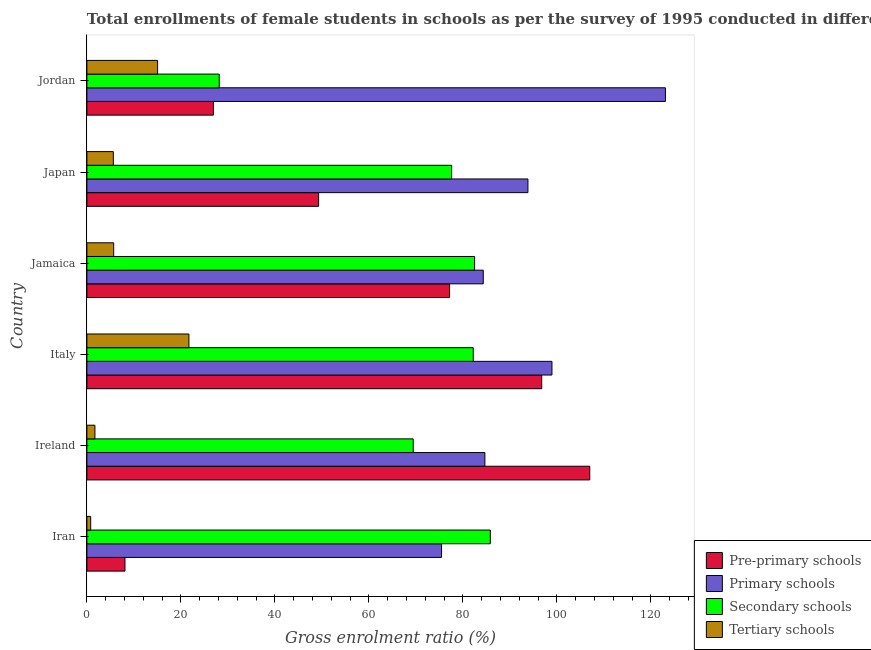Are the number of bars per tick equal to the number of legend labels?
Your response must be concise. Yes. How many bars are there on the 5th tick from the bottom?
Provide a short and direct response. 4. What is the label of the 4th group of bars from the top?
Make the answer very short. Italy. In how many cases, is the number of bars for a given country not equal to the number of legend labels?
Your response must be concise. 0. What is the gross enrolment ratio(female) in primary schools in Italy?
Offer a very short reply. 98.95. Across all countries, what is the maximum gross enrolment ratio(female) in pre-primary schools?
Make the answer very short. 106.99. Across all countries, what is the minimum gross enrolment ratio(female) in pre-primary schools?
Your answer should be very brief. 8.1. In which country was the gross enrolment ratio(female) in pre-primary schools maximum?
Offer a terse response. Ireland. In which country was the gross enrolment ratio(female) in tertiary schools minimum?
Your answer should be very brief. Iran. What is the total gross enrolment ratio(female) in pre-primary schools in the graph?
Your answer should be compact. 365.24. What is the difference between the gross enrolment ratio(female) in primary schools in Japan and that in Jordan?
Your answer should be very brief. -29.25. What is the difference between the gross enrolment ratio(female) in primary schools in Ireland and the gross enrolment ratio(female) in tertiary schools in Jordan?
Your response must be concise. 69.64. What is the average gross enrolment ratio(female) in primary schools per country?
Ensure brevity in your answer.  93.39. What is the difference between the gross enrolment ratio(female) in primary schools and gross enrolment ratio(female) in pre-primary schools in Jordan?
Keep it short and to the point. 96.18. What is the ratio of the gross enrolment ratio(female) in primary schools in Iran to that in Ireland?
Your answer should be very brief. 0.89. Is the difference between the gross enrolment ratio(female) in secondary schools in Iran and Japan greater than the difference between the gross enrolment ratio(female) in pre-primary schools in Iran and Japan?
Your response must be concise. Yes. What is the difference between the highest and the second highest gross enrolment ratio(female) in primary schools?
Ensure brevity in your answer.  24.14. What is the difference between the highest and the lowest gross enrolment ratio(female) in tertiary schools?
Give a very brief answer. 20.9. What does the 2nd bar from the top in Japan represents?
Offer a terse response. Secondary schools. What does the 2nd bar from the bottom in Jamaica represents?
Provide a succinct answer. Primary schools. Is it the case that in every country, the sum of the gross enrolment ratio(female) in pre-primary schools and gross enrolment ratio(female) in primary schools is greater than the gross enrolment ratio(female) in secondary schools?
Ensure brevity in your answer.  No. Does the graph contain grids?
Your answer should be very brief. No. How many legend labels are there?
Keep it short and to the point. 4. What is the title of the graph?
Provide a short and direct response. Total enrollments of female students in schools as per the survey of 1995 conducted in different countries. What is the label or title of the Y-axis?
Ensure brevity in your answer.  Country. What is the Gross enrolment ratio (%) of Pre-primary schools in Iran?
Give a very brief answer. 8.1. What is the Gross enrolment ratio (%) of Primary schools in Iran?
Ensure brevity in your answer.  75.46. What is the Gross enrolment ratio (%) of Secondary schools in Iran?
Offer a terse response. 85.83. What is the Gross enrolment ratio (%) in Tertiary schools in Iran?
Your answer should be compact. 0.81. What is the Gross enrolment ratio (%) of Pre-primary schools in Ireland?
Give a very brief answer. 106.99. What is the Gross enrolment ratio (%) of Primary schools in Ireland?
Keep it short and to the point. 84.68. What is the Gross enrolment ratio (%) in Secondary schools in Ireland?
Give a very brief answer. 69.43. What is the Gross enrolment ratio (%) of Tertiary schools in Ireland?
Keep it short and to the point. 1.71. What is the Gross enrolment ratio (%) in Pre-primary schools in Italy?
Keep it short and to the point. 96.77. What is the Gross enrolment ratio (%) of Primary schools in Italy?
Offer a very short reply. 98.95. What is the Gross enrolment ratio (%) of Secondary schools in Italy?
Keep it short and to the point. 82.2. What is the Gross enrolment ratio (%) of Tertiary schools in Italy?
Keep it short and to the point. 21.71. What is the Gross enrolment ratio (%) of Pre-primary schools in Jamaica?
Offer a terse response. 77.16. What is the Gross enrolment ratio (%) in Primary schools in Jamaica?
Make the answer very short. 84.33. What is the Gross enrolment ratio (%) in Secondary schools in Jamaica?
Your response must be concise. 82.49. What is the Gross enrolment ratio (%) of Tertiary schools in Jamaica?
Your answer should be very brief. 5.7. What is the Gross enrolment ratio (%) in Pre-primary schools in Japan?
Provide a succinct answer. 49.3. What is the Gross enrolment ratio (%) of Primary schools in Japan?
Keep it short and to the point. 93.84. What is the Gross enrolment ratio (%) in Secondary schools in Japan?
Your answer should be compact. 77.61. What is the Gross enrolment ratio (%) in Tertiary schools in Japan?
Ensure brevity in your answer.  5.63. What is the Gross enrolment ratio (%) of Pre-primary schools in Jordan?
Provide a short and direct response. 26.91. What is the Gross enrolment ratio (%) of Primary schools in Jordan?
Ensure brevity in your answer.  123.09. What is the Gross enrolment ratio (%) of Secondary schools in Jordan?
Give a very brief answer. 28.15. What is the Gross enrolment ratio (%) in Tertiary schools in Jordan?
Give a very brief answer. 15.04. Across all countries, what is the maximum Gross enrolment ratio (%) of Pre-primary schools?
Provide a short and direct response. 106.99. Across all countries, what is the maximum Gross enrolment ratio (%) of Primary schools?
Keep it short and to the point. 123.09. Across all countries, what is the maximum Gross enrolment ratio (%) in Secondary schools?
Offer a very short reply. 85.83. Across all countries, what is the maximum Gross enrolment ratio (%) in Tertiary schools?
Give a very brief answer. 21.71. Across all countries, what is the minimum Gross enrolment ratio (%) in Pre-primary schools?
Keep it short and to the point. 8.1. Across all countries, what is the minimum Gross enrolment ratio (%) in Primary schools?
Keep it short and to the point. 75.46. Across all countries, what is the minimum Gross enrolment ratio (%) in Secondary schools?
Keep it short and to the point. 28.15. Across all countries, what is the minimum Gross enrolment ratio (%) of Tertiary schools?
Ensure brevity in your answer.  0.81. What is the total Gross enrolment ratio (%) of Pre-primary schools in the graph?
Offer a terse response. 365.24. What is the total Gross enrolment ratio (%) of Primary schools in the graph?
Provide a short and direct response. 560.35. What is the total Gross enrolment ratio (%) of Secondary schools in the graph?
Ensure brevity in your answer.  425.71. What is the total Gross enrolment ratio (%) in Tertiary schools in the graph?
Your response must be concise. 50.59. What is the difference between the Gross enrolment ratio (%) of Pre-primary schools in Iran and that in Ireland?
Give a very brief answer. -98.89. What is the difference between the Gross enrolment ratio (%) in Primary schools in Iran and that in Ireland?
Make the answer very short. -9.22. What is the difference between the Gross enrolment ratio (%) in Secondary schools in Iran and that in Ireland?
Offer a very short reply. 16.41. What is the difference between the Gross enrolment ratio (%) in Tertiary schools in Iran and that in Ireland?
Your answer should be compact. -0.9. What is the difference between the Gross enrolment ratio (%) of Pre-primary schools in Iran and that in Italy?
Your response must be concise. -88.67. What is the difference between the Gross enrolment ratio (%) of Primary schools in Iran and that in Italy?
Offer a very short reply. -23.49. What is the difference between the Gross enrolment ratio (%) in Secondary schools in Iran and that in Italy?
Ensure brevity in your answer.  3.63. What is the difference between the Gross enrolment ratio (%) in Tertiary schools in Iran and that in Italy?
Make the answer very short. -20.9. What is the difference between the Gross enrolment ratio (%) in Pre-primary schools in Iran and that in Jamaica?
Provide a succinct answer. -69.06. What is the difference between the Gross enrolment ratio (%) in Primary schools in Iran and that in Jamaica?
Keep it short and to the point. -8.88. What is the difference between the Gross enrolment ratio (%) of Secondary schools in Iran and that in Jamaica?
Provide a succinct answer. 3.34. What is the difference between the Gross enrolment ratio (%) in Tertiary schools in Iran and that in Jamaica?
Your answer should be compact. -4.89. What is the difference between the Gross enrolment ratio (%) in Pre-primary schools in Iran and that in Japan?
Provide a succinct answer. -41.2. What is the difference between the Gross enrolment ratio (%) of Primary schools in Iran and that in Japan?
Your answer should be compact. -18.38. What is the difference between the Gross enrolment ratio (%) of Secondary schools in Iran and that in Japan?
Ensure brevity in your answer.  8.23. What is the difference between the Gross enrolment ratio (%) in Tertiary schools in Iran and that in Japan?
Your response must be concise. -4.82. What is the difference between the Gross enrolment ratio (%) in Pre-primary schools in Iran and that in Jordan?
Give a very brief answer. -18.81. What is the difference between the Gross enrolment ratio (%) of Primary schools in Iran and that in Jordan?
Make the answer very short. -47.63. What is the difference between the Gross enrolment ratio (%) of Secondary schools in Iran and that in Jordan?
Ensure brevity in your answer.  57.68. What is the difference between the Gross enrolment ratio (%) in Tertiary schools in Iran and that in Jordan?
Your response must be concise. -14.23. What is the difference between the Gross enrolment ratio (%) in Pre-primary schools in Ireland and that in Italy?
Make the answer very short. 10.22. What is the difference between the Gross enrolment ratio (%) in Primary schools in Ireland and that in Italy?
Offer a very short reply. -14.27. What is the difference between the Gross enrolment ratio (%) in Secondary schools in Ireland and that in Italy?
Offer a terse response. -12.77. What is the difference between the Gross enrolment ratio (%) of Tertiary schools in Ireland and that in Italy?
Your answer should be very brief. -20. What is the difference between the Gross enrolment ratio (%) in Pre-primary schools in Ireland and that in Jamaica?
Provide a short and direct response. 29.83. What is the difference between the Gross enrolment ratio (%) of Primary schools in Ireland and that in Jamaica?
Your answer should be very brief. 0.35. What is the difference between the Gross enrolment ratio (%) in Secondary schools in Ireland and that in Jamaica?
Keep it short and to the point. -13.07. What is the difference between the Gross enrolment ratio (%) in Tertiary schools in Ireland and that in Jamaica?
Make the answer very short. -3.99. What is the difference between the Gross enrolment ratio (%) in Pre-primary schools in Ireland and that in Japan?
Provide a succinct answer. 57.69. What is the difference between the Gross enrolment ratio (%) in Primary schools in Ireland and that in Japan?
Ensure brevity in your answer.  -9.16. What is the difference between the Gross enrolment ratio (%) in Secondary schools in Ireland and that in Japan?
Keep it short and to the point. -8.18. What is the difference between the Gross enrolment ratio (%) of Tertiary schools in Ireland and that in Japan?
Ensure brevity in your answer.  -3.92. What is the difference between the Gross enrolment ratio (%) in Pre-primary schools in Ireland and that in Jordan?
Make the answer very short. 80.08. What is the difference between the Gross enrolment ratio (%) of Primary schools in Ireland and that in Jordan?
Offer a very short reply. -38.41. What is the difference between the Gross enrolment ratio (%) in Secondary schools in Ireland and that in Jordan?
Ensure brevity in your answer.  41.27. What is the difference between the Gross enrolment ratio (%) in Tertiary schools in Ireland and that in Jordan?
Offer a very short reply. -13.33. What is the difference between the Gross enrolment ratio (%) of Pre-primary schools in Italy and that in Jamaica?
Your response must be concise. 19.61. What is the difference between the Gross enrolment ratio (%) of Primary schools in Italy and that in Jamaica?
Keep it short and to the point. 14.62. What is the difference between the Gross enrolment ratio (%) in Secondary schools in Italy and that in Jamaica?
Ensure brevity in your answer.  -0.29. What is the difference between the Gross enrolment ratio (%) in Tertiary schools in Italy and that in Jamaica?
Provide a succinct answer. 16.01. What is the difference between the Gross enrolment ratio (%) in Pre-primary schools in Italy and that in Japan?
Offer a terse response. 47.47. What is the difference between the Gross enrolment ratio (%) in Primary schools in Italy and that in Japan?
Offer a terse response. 5.11. What is the difference between the Gross enrolment ratio (%) of Secondary schools in Italy and that in Japan?
Give a very brief answer. 4.59. What is the difference between the Gross enrolment ratio (%) of Tertiary schools in Italy and that in Japan?
Offer a terse response. 16.08. What is the difference between the Gross enrolment ratio (%) of Pre-primary schools in Italy and that in Jordan?
Keep it short and to the point. 69.86. What is the difference between the Gross enrolment ratio (%) in Primary schools in Italy and that in Jordan?
Give a very brief answer. -24.14. What is the difference between the Gross enrolment ratio (%) of Secondary schools in Italy and that in Jordan?
Offer a very short reply. 54.04. What is the difference between the Gross enrolment ratio (%) in Tertiary schools in Italy and that in Jordan?
Provide a succinct answer. 6.67. What is the difference between the Gross enrolment ratio (%) of Pre-primary schools in Jamaica and that in Japan?
Provide a short and direct response. 27.86. What is the difference between the Gross enrolment ratio (%) in Primary schools in Jamaica and that in Japan?
Keep it short and to the point. -9.5. What is the difference between the Gross enrolment ratio (%) in Secondary schools in Jamaica and that in Japan?
Provide a short and direct response. 4.89. What is the difference between the Gross enrolment ratio (%) in Tertiary schools in Jamaica and that in Japan?
Offer a terse response. 0.07. What is the difference between the Gross enrolment ratio (%) of Pre-primary schools in Jamaica and that in Jordan?
Your response must be concise. 50.25. What is the difference between the Gross enrolment ratio (%) in Primary schools in Jamaica and that in Jordan?
Offer a terse response. -38.76. What is the difference between the Gross enrolment ratio (%) in Secondary schools in Jamaica and that in Jordan?
Provide a short and direct response. 54.34. What is the difference between the Gross enrolment ratio (%) in Tertiary schools in Jamaica and that in Jordan?
Offer a very short reply. -9.34. What is the difference between the Gross enrolment ratio (%) of Pre-primary schools in Japan and that in Jordan?
Provide a short and direct response. 22.39. What is the difference between the Gross enrolment ratio (%) of Primary schools in Japan and that in Jordan?
Your answer should be very brief. -29.25. What is the difference between the Gross enrolment ratio (%) of Secondary schools in Japan and that in Jordan?
Your answer should be very brief. 49.45. What is the difference between the Gross enrolment ratio (%) of Tertiary schools in Japan and that in Jordan?
Offer a terse response. -9.42. What is the difference between the Gross enrolment ratio (%) in Pre-primary schools in Iran and the Gross enrolment ratio (%) in Primary schools in Ireland?
Provide a short and direct response. -76.58. What is the difference between the Gross enrolment ratio (%) of Pre-primary schools in Iran and the Gross enrolment ratio (%) of Secondary schools in Ireland?
Provide a succinct answer. -61.32. What is the difference between the Gross enrolment ratio (%) of Pre-primary schools in Iran and the Gross enrolment ratio (%) of Tertiary schools in Ireland?
Give a very brief answer. 6.39. What is the difference between the Gross enrolment ratio (%) of Primary schools in Iran and the Gross enrolment ratio (%) of Secondary schools in Ireland?
Give a very brief answer. 6.03. What is the difference between the Gross enrolment ratio (%) of Primary schools in Iran and the Gross enrolment ratio (%) of Tertiary schools in Ireland?
Provide a succinct answer. 73.75. What is the difference between the Gross enrolment ratio (%) in Secondary schools in Iran and the Gross enrolment ratio (%) in Tertiary schools in Ireland?
Your answer should be compact. 84.12. What is the difference between the Gross enrolment ratio (%) in Pre-primary schools in Iran and the Gross enrolment ratio (%) in Primary schools in Italy?
Provide a short and direct response. -90.85. What is the difference between the Gross enrolment ratio (%) in Pre-primary schools in Iran and the Gross enrolment ratio (%) in Secondary schools in Italy?
Offer a terse response. -74.1. What is the difference between the Gross enrolment ratio (%) in Pre-primary schools in Iran and the Gross enrolment ratio (%) in Tertiary schools in Italy?
Your answer should be very brief. -13.61. What is the difference between the Gross enrolment ratio (%) of Primary schools in Iran and the Gross enrolment ratio (%) of Secondary schools in Italy?
Your response must be concise. -6.74. What is the difference between the Gross enrolment ratio (%) of Primary schools in Iran and the Gross enrolment ratio (%) of Tertiary schools in Italy?
Ensure brevity in your answer.  53.75. What is the difference between the Gross enrolment ratio (%) of Secondary schools in Iran and the Gross enrolment ratio (%) of Tertiary schools in Italy?
Provide a short and direct response. 64.12. What is the difference between the Gross enrolment ratio (%) of Pre-primary schools in Iran and the Gross enrolment ratio (%) of Primary schools in Jamaica?
Provide a short and direct response. -76.23. What is the difference between the Gross enrolment ratio (%) of Pre-primary schools in Iran and the Gross enrolment ratio (%) of Secondary schools in Jamaica?
Your answer should be very brief. -74.39. What is the difference between the Gross enrolment ratio (%) in Pre-primary schools in Iran and the Gross enrolment ratio (%) in Tertiary schools in Jamaica?
Your answer should be very brief. 2.4. What is the difference between the Gross enrolment ratio (%) of Primary schools in Iran and the Gross enrolment ratio (%) of Secondary schools in Jamaica?
Keep it short and to the point. -7.03. What is the difference between the Gross enrolment ratio (%) in Primary schools in Iran and the Gross enrolment ratio (%) in Tertiary schools in Jamaica?
Provide a short and direct response. 69.76. What is the difference between the Gross enrolment ratio (%) of Secondary schools in Iran and the Gross enrolment ratio (%) of Tertiary schools in Jamaica?
Your answer should be compact. 80.13. What is the difference between the Gross enrolment ratio (%) in Pre-primary schools in Iran and the Gross enrolment ratio (%) in Primary schools in Japan?
Make the answer very short. -85.74. What is the difference between the Gross enrolment ratio (%) of Pre-primary schools in Iran and the Gross enrolment ratio (%) of Secondary schools in Japan?
Your answer should be very brief. -69.5. What is the difference between the Gross enrolment ratio (%) of Pre-primary schools in Iran and the Gross enrolment ratio (%) of Tertiary schools in Japan?
Give a very brief answer. 2.48. What is the difference between the Gross enrolment ratio (%) in Primary schools in Iran and the Gross enrolment ratio (%) in Secondary schools in Japan?
Provide a succinct answer. -2.15. What is the difference between the Gross enrolment ratio (%) in Primary schools in Iran and the Gross enrolment ratio (%) in Tertiary schools in Japan?
Your answer should be very brief. 69.83. What is the difference between the Gross enrolment ratio (%) in Secondary schools in Iran and the Gross enrolment ratio (%) in Tertiary schools in Japan?
Ensure brevity in your answer.  80.21. What is the difference between the Gross enrolment ratio (%) in Pre-primary schools in Iran and the Gross enrolment ratio (%) in Primary schools in Jordan?
Make the answer very short. -114.99. What is the difference between the Gross enrolment ratio (%) in Pre-primary schools in Iran and the Gross enrolment ratio (%) in Secondary schools in Jordan?
Your answer should be very brief. -20.05. What is the difference between the Gross enrolment ratio (%) of Pre-primary schools in Iran and the Gross enrolment ratio (%) of Tertiary schools in Jordan?
Ensure brevity in your answer.  -6.94. What is the difference between the Gross enrolment ratio (%) in Primary schools in Iran and the Gross enrolment ratio (%) in Secondary schools in Jordan?
Offer a very short reply. 47.3. What is the difference between the Gross enrolment ratio (%) in Primary schools in Iran and the Gross enrolment ratio (%) in Tertiary schools in Jordan?
Make the answer very short. 60.42. What is the difference between the Gross enrolment ratio (%) in Secondary schools in Iran and the Gross enrolment ratio (%) in Tertiary schools in Jordan?
Offer a very short reply. 70.79. What is the difference between the Gross enrolment ratio (%) of Pre-primary schools in Ireland and the Gross enrolment ratio (%) of Primary schools in Italy?
Offer a terse response. 8.04. What is the difference between the Gross enrolment ratio (%) of Pre-primary schools in Ireland and the Gross enrolment ratio (%) of Secondary schools in Italy?
Make the answer very short. 24.79. What is the difference between the Gross enrolment ratio (%) in Pre-primary schools in Ireland and the Gross enrolment ratio (%) in Tertiary schools in Italy?
Provide a succinct answer. 85.28. What is the difference between the Gross enrolment ratio (%) of Primary schools in Ireland and the Gross enrolment ratio (%) of Secondary schools in Italy?
Give a very brief answer. 2.48. What is the difference between the Gross enrolment ratio (%) of Primary schools in Ireland and the Gross enrolment ratio (%) of Tertiary schools in Italy?
Your answer should be compact. 62.97. What is the difference between the Gross enrolment ratio (%) in Secondary schools in Ireland and the Gross enrolment ratio (%) in Tertiary schools in Italy?
Offer a very short reply. 47.72. What is the difference between the Gross enrolment ratio (%) of Pre-primary schools in Ireland and the Gross enrolment ratio (%) of Primary schools in Jamaica?
Make the answer very short. 22.66. What is the difference between the Gross enrolment ratio (%) of Pre-primary schools in Ireland and the Gross enrolment ratio (%) of Secondary schools in Jamaica?
Your response must be concise. 24.5. What is the difference between the Gross enrolment ratio (%) in Pre-primary schools in Ireland and the Gross enrolment ratio (%) in Tertiary schools in Jamaica?
Give a very brief answer. 101.29. What is the difference between the Gross enrolment ratio (%) in Primary schools in Ireland and the Gross enrolment ratio (%) in Secondary schools in Jamaica?
Your answer should be very brief. 2.19. What is the difference between the Gross enrolment ratio (%) of Primary schools in Ireland and the Gross enrolment ratio (%) of Tertiary schools in Jamaica?
Provide a short and direct response. 78.98. What is the difference between the Gross enrolment ratio (%) of Secondary schools in Ireland and the Gross enrolment ratio (%) of Tertiary schools in Jamaica?
Offer a very short reply. 63.73. What is the difference between the Gross enrolment ratio (%) in Pre-primary schools in Ireland and the Gross enrolment ratio (%) in Primary schools in Japan?
Give a very brief answer. 13.15. What is the difference between the Gross enrolment ratio (%) of Pre-primary schools in Ireland and the Gross enrolment ratio (%) of Secondary schools in Japan?
Give a very brief answer. 29.38. What is the difference between the Gross enrolment ratio (%) in Pre-primary schools in Ireland and the Gross enrolment ratio (%) in Tertiary schools in Japan?
Offer a terse response. 101.37. What is the difference between the Gross enrolment ratio (%) in Primary schools in Ireland and the Gross enrolment ratio (%) in Secondary schools in Japan?
Ensure brevity in your answer.  7.07. What is the difference between the Gross enrolment ratio (%) of Primary schools in Ireland and the Gross enrolment ratio (%) of Tertiary schools in Japan?
Your answer should be compact. 79.05. What is the difference between the Gross enrolment ratio (%) of Secondary schools in Ireland and the Gross enrolment ratio (%) of Tertiary schools in Japan?
Your response must be concise. 63.8. What is the difference between the Gross enrolment ratio (%) in Pre-primary schools in Ireland and the Gross enrolment ratio (%) in Primary schools in Jordan?
Your response must be concise. -16.1. What is the difference between the Gross enrolment ratio (%) of Pre-primary schools in Ireland and the Gross enrolment ratio (%) of Secondary schools in Jordan?
Ensure brevity in your answer.  78.84. What is the difference between the Gross enrolment ratio (%) of Pre-primary schools in Ireland and the Gross enrolment ratio (%) of Tertiary schools in Jordan?
Your answer should be compact. 91.95. What is the difference between the Gross enrolment ratio (%) of Primary schools in Ireland and the Gross enrolment ratio (%) of Secondary schools in Jordan?
Your answer should be very brief. 56.52. What is the difference between the Gross enrolment ratio (%) of Primary schools in Ireland and the Gross enrolment ratio (%) of Tertiary schools in Jordan?
Make the answer very short. 69.64. What is the difference between the Gross enrolment ratio (%) of Secondary schools in Ireland and the Gross enrolment ratio (%) of Tertiary schools in Jordan?
Make the answer very short. 54.38. What is the difference between the Gross enrolment ratio (%) in Pre-primary schools in Italy and the Gross enrolment ratio (%) in Primary schools in Jamaica?
Ensure brevity in your answer.  12.44. What is the difference between the Gross enrolment ratio (%) in Pre-primary schools in Italy and the Gross enrolment ratio (%) in Secondary schools in Jamaica?
Your answer should be very brief. 14.28. What is the difference between the Gross enrolment ratio (%) in Pre-primary schools in Italy and the Gross enrolment ratio (%) in Tertiary schools in Jamaica?
Offer a very short reply. 91.07. What is the difference between the Gross enrolment ratio (%) in Primary schools in Italy and the Gross enrolment ratio (%) in Secondary schools in Jamaica?
Keep it short and to the point. 16.46. What is the difference between the Gross enrolment ratio (%) in Primary schools in Italy and the Gross enrolment ratio (%) in Tertiary schools in Jamaica?
Provide a short and direct response. 93.25. What is the difference between the Gross enrolment ratio (%) of Secondary schools in Italy and the Gross enrolment ratio (%) of Tertiary schools in Jamaica?
Provide a short and direct response. 76.5. What is the difference between the Gross enrolment ratio (%) of Pre-primary schools in Italy and the Gross enrolment ratio (%) of Primary schools in Japan?
Offer a very short reply. 2.93. What is the difference between the Gross enrolment ratio (%) of Pre-primary schools in Italy and the Gross enrolment ratio (%) of Secondary schools in Japan?
Make the answer very short. 19.16. What is the difference between the Gross enrolment ratio (%) in Pre-primary schools in Italy and the Gross enrolment ratio (%) in Tertiary schools in Japan?
Your response must be concise. 91.14. What is the difference between the Gross enrolment ratio (%) in Primary schools in Italy and the Gross enrolment ratio (%) in Secondary schools in Japan?
Your answer should be very brief. 21.35. What is the difference between the Gross enrolment ratio (%) in Primary schools in Italy and the Gross enrolment ratio (%) in Tertiary schools in Japan?
Offer a very short reply. 93.33. What is the difference between the Gross enrolment ratio (%) of Secondary schools in Italy and the Gross enrolment ratio (%) of Tertiary schools in Japan?
Provide a succinct answer. 76.57. What is the difference between the Gross enrolment ratio (%) in Pre-primary schools in Italy and the Gross enrolment ratio (%) in Primary schools in Jordan?
Offer a very short reply. -26.32. What is the difference between the Gross enrolment ratio (%) in Pre-primary schools in Italy and the Gross enrolment ratio (%) in Secondary schools in Jordan?
Provide a short and direct response. 68.62. What is the difference between the Gross enrolment ratio (%) of Pre-primary schools in Italy and the Gross enrolment ratio (%) of Tertiary schools in Jordan?
Provide a short and direct response. 81.73. What is the difference between the Gross enrolment ratio (%) in Primary schools in Italy and the Gross enrolment ratio (%) in Secondary schools in Jordan?
Your answer should be compact. 70.8. What is the difference between the Gross enrolment ratio (%) in Primary schools in Italy and the Gross enrolment ratio (%) in Tertiary schools in Jordan?
Your response must be concise. 83.91. What is the difference between the Gross enrolment ratio (%) in Secondary schools in Italy and the Gross enrolment ratio (%) in Tertiary schools in Jordan?
Provide a short and direct response. 67.16. What is the difference between the Gross enrolment ratio (%) of Pre-primary schools in Jamaica and the Gross enrolment ratio (%) of Primary schools in Japan?
Provide a succinct answer. -16.67. What is the difference between the Gross enrolment ratio (%) of Pre-primary schools in Jamaica and the Gross enrolment ratio (%) of Secondary schools in Japan?
Give a very brief answer. -0.44. What is the difference between the Gross enrolment ratio (%) in Pre-primary schools in Jamaica and the Gross enrolment ratio (%) in Tertiary schools in Japan?
Offer a terse response. 71.54. What is the difference between the Gross enrolment ratio (%) of Primary schools in Jamaica and the Gross enrolment ratio (%) of Secondary schools in Japan?
Keep it short and to the point. 6.73. What is the difference between the Gross enrolment ratio (%) of Primary schools in Jamaica and the Gross enrolment ratio (%) of Tertiary schools in Japan?
Your answer should be very brief. 78.71. What is the difference between the Gross enrolment ratio (%) in Secondary schools in Jamaica and the Gross enrolment ratio (%) in Tertiary schools in Japan?
Your answer should be very brief. 76.87. What is the difference between the Gross enrolment ratio (%) of Pre-primary schools in Jamaica and the Gross enrolment ratio (%) of Primary schools in Jordan?
Offer a terse response. -45.93. What is the difference between the Gross enrolment ratio (%) of Pre-primary schools in Jamaica and the Gross enrolment ratio (%) of Secondary schools in Jordan?
Offer a terse response. 49.01. What is the difference between the Gross enrolment ratio (%) in Pre-primary schools in Jamaica and the Gross enrolment ratio (%) in Tertiary schools in Jordan?
Offer a very short reply. 62.12. What is the difference between the Gross enrolment ratio (%) of Primary schools in Jamaica and the Gross enrolment ratio (%) of Secondary schools in Jordan?
Ensure brevity in your answer.  56.18. What is the difference between the Gross enrolment ratio (%) of Primary schools in Jamaica and the Gross enrolment ratio (%) of Tertiary schools in Jordan?
Your response must be concise. 69.29. What is the difference between the Gross enrolment ratio (%) in Secondary schools in Jamaica and the Gross enrolment ratio (%) in Tertiary schools in Jordan?
Provide a succinct answer. 67.45. What is the difference between the Gross enrolment ratio (%) of Pre-primary schools in Japan and the Gross enrolment ratio (%) of Primary schools in Jordan?
Offer a very short reply. -73.79. What is the difference between the Gross enrolment ratio (%) in Pre-primary schools in Japan and the Gross enrolment ratio (%) in Secondary schools in Jordan?
Keep it short and to the point. 21.15. What is the difference between the Gross enrolment ratio (%) in Pre-primary schools in Japan and the Gross enrolment ratio (%) in Tertiary schools in Jordan?
Provide a short and direct response. 34.26. What is the difference between the Gross enrolment ratio (%) in Primary schools in Japan and the Gross enrolment ratio (%) in Secondary schools in Jordan?
Offer a very short reply. 65.68. What is the difference between the Gross enrolment ratio (%) in Primary schools in Japan and the Gross enrolment ratio (%) in Tertiary schools in Jordan?
Keep it short and to the point. 78.8. What is the difference between the Gross enrolment ratio (%) of Secondary schools in Japan and the Gross enrolment ratio (%) of Tertiary schools in Jordan?
Provide a short and direct response. 62.56. What is the average Gross enrolment ratio (%) in Pre-primary schools per country?
Ensure brevity in your answer.  60.87. What is the average Gross enrolment ratio (%) of Primary schools per country?
Offer a terse response. 93.39. What is the average Gross enrolment ratio (%) of Secondary schools per country?
Your answer should be compact. 70.95. What is the average Gross enrolment ratio (%) of Tertiary schools per country?
Provide a short and direct response. 8.43. What is the difference between the Gross enrolment ratio (%) in Pre-primary schools and Gross enrolment ratio (%) in Primary schools in Iran?
Make the answer very short. -67.36. What is the difference between the Gross enrolment ratio (%) of Pre-primary schools and Gross enrolment ratio (%) of Secondary schools in Iran?
Your answer should be compact. -77.73. What is the difference between the Gross enrolment ratio (%) in Pre-primary schools and Gross enrolment ratio (%) in Tertiary schools in Iran?
Provide a short and direct response. 7.29. What is the difference between the Gross enrolment ratio (%) in Primary schools and Gross enrolment ratio (%) in Secondary schools in Iran?
Provide a succinct answer. -10.37. What is the difference between the Gross enrolment ratio (%) in Primary schools and Gross enrolment ratio (%) in Tertiary schools in Iran?
Your answer should be compact. 74.65. What is the difference between the Gross enrolment ratio (%) of Secondary schools and Gross enrolment ratio (%) of Tertiary schools in Iran?
Offer a terse response. 85.02. What is the difference between the Gross enrolment ratio (%) of Pre-primary schools and Gross enrolment ratio (%) of Primary schools in Ireland?
Your answer should be very brief. 22.31. What is the difference between the Gross enrolment ratio (%) in Pre-primary schools and Gross enrolment ratio (%) in Secondary schools in Ireland?
Provide a short and direct response. 37.56. What is the difference between the Gross enrolment ratio (%) of Pre-primary schools and Gross enrolment ratio (%) of Tertiary schools in Ireland?
Keep it short and to the point. 105.28. What is the difference between the Gross enrolment ratio (%) of Primary schools and Gross enrolment ratio (%) of Secondary schools in Ireland?
Your response must be concise. 15.25. What is the difference between the Gross enrolment ratio (%) in Primary schools and Gross enrolment ratio (%) in Tertiary schools in Ireland?
Offer a very short reply. 82.97. What is the difference between the Gross enrolment ratio (%) in Secondary schools and Gross enrolment ratio (%) in Tertiary schools in Ireland?
Give a very brief answer. 67.72. What is the difference between the Gross enrolment ratio (%) of Pre-primary schools and Gross enrolment ratio (%) of Primary schools in Italy?
Provide a short and direct response. -2.18. What is the difference between the Gross enrolment ratio (%) in Pre-primary schools and Gross enrolment ratio (%) in Secondary schools in Italy?
Your answer should be compact. 14.57. What is the difference between the Gross enrolment ratio (%) of Pre-primary schools and Gross enrolment ratio (%) of Tertiary schools in Italy?
Your answer should be compact. 75.06. What is the difference between the Gross enrolment ratio (%) of Primary schools and Gross enrolment ratio (%) of Secondary schools in Italy?
Make the answer very short. 16.75. What is the difference between the Gross enrolment ratio (%) in Primary schools and Gross enrolment ratio (%) in Tertiary schools in Italy?
Make the answer very short. 77.24. What is the difference between the Gross enrolment ratio (%) in Secondary schools and Gross enrolment ratio (%) in Tertiary schools in Italy?
Provide a short and direct response. 60.49. What is the difference between the Gross enrolment ratio (%) of Pre-primary schools and Gross enrolment ratio (%) of Primary schools in Jamaica?
Ensure brevity in your answer.  -7.17. What is the difference between the Gross enrolment ratio (%) of Pre-primary schools and Gross enrolment ratio (%) of Secondary schools in Jamaica?
Your response must be concise. -5.33. What is the difference between the Gross enrolment ratio (%) of Pre-primary schools and Gross enrolment ratio (%) of Tertiary schools in Jamaica?
Offer a terse response. 71.46. What is the difference between the Gross enrolment ratio (%) in Primary schools and Gross enrolment ratio (%) in Secondary schools in Jamaica?
Offer a terse response. 1.84. What is the difference between the Gross enrolment ratio (%) in Primary schools and Gross enrolment ratio (%) in Tertiary schools in Jamaica?
Provide a short and direct response. 78.63. What is the difference between the Gross enrolment ratio (%) in Secondary schools and Gross enrolment ratio (%) in Tertiary schools in Jamaica?
Your answer should be compact. 76.79. What is the difference between the Gross enrolment ratio (%) of Pre-primary schools and Gross enrolment ratio (%) of Primary schools in Japan?
Offer a terse response. -44.54. What is the difference between the Gross enrolment ratio (%) of Pre-primary schools and Gross enrolment ratio (%) of Secondary schools in Japan?
Keep it short and to the point. -28.3. What is the difference between the Gross enrolment ratio (%) of Pre-primary schools and Gross enrolment ratio (%) of Tertiary schools in Japan?
Offer a very short reply. 43.68. What is the difference between the Gross enrolment ratio (%) in Primary schools and Gross enrolment ratio (%) in Secondary schools in Japan?
Your answer should be compact. 16.23. What is the difference between the Gross enrolment ratio (%) of Primary schools and Gross enrolment ratio (%) of Tertiary schools in Japan?
Give a very brief answer. 88.21. What is the difference between the Gross enrolment ratio (%) in Secondary schools and Gross enrolment ratio (%) in Tertiary schools in Japan?
Give a very brief answer. 71.98. What is the difference between the Gross enrolment ratio (%) in Pre-primary schools and Gross enrolment ratio (%) in Primary schools in Jordan?
Provide a short and direct response. -96.18. What is the difference between the Gross enrolment ratio (%) of Pre-primary schools and Gross enrolment ratio (%) of Secondary schools in Jordan?
Ensure brevity in your answer.  -1.24. What is the difference between the Gross enrolment ratio (%) of Pre-primary schools and Gross enrolment ratio (%) of Tertiary schools in Jordan?
Give a very brief answer. 11.87. What is the difference between the Gross enrolment ratio (%) in Primary schools and Gross enrolment ratio (%) in Secondary schools in Jordan?
Offer a very short reply. 94.94. What is the difference between the Gross enrolment ratio (%) of Primary schools and Gross enrolment ratio (%) of Tertiary schools in Jordan?
Your response must be concise. 108.05. What is the difference between the Gross enrolment ratio (%) in Secondary schools and Gross enrolment ratio (%) in Tertiary schools in Jordan?
Ensure brevity in your answer.  13.11. What is the ratio of the Gross enrolment ratio (%) of Pre-primary schools in Iran to that in Ireland?
Give a very brief answer. 0.08. What is the ratio of the Gross enrolment ratio (%) of Primary schools in Iran to that in Ireland?
Give a very brief answer. 0.89. What is the ratio of the Gross enrolment ratio (%) of Secondary schools in Iran to that in Ireland?
Offer a terse response. 1.24. What is the ratio of the Gross enrolment ratio (%) in Tertiary schools in Iran to that in Ireland?
Your answer should be compact. 0.47. What is the ratio of the Gross enrolment ratio (%) of Pre-primary schools in Iran to that in Italy?
Give a very brief answer. 0.08. What is the ratio of the Gross enrolment ratio (%) in Primary schools in Iran to that in Italy?
Provide a succinct answer. 0.76. What is the ratio of the Gross enrolment ratio (%) of Secondary schools in Iran to that in Italy?
Make the answer very short. 1.04. What is the ratio of the Gross enrolment ratio (%) of Tertiary schools in Iran to that in Italy?
Make the answer very short. 0.04. What is the ratio of the Gross enrolment ratio (%) in Pre-primary schools in Iran to that in Jamaica?
Your response must be concise. 0.1. What is the ratio of the Gross enrolment ratio (%) in Primary schools in Iran to that in Jamaica?
Make the answer very short. 0.89. What is the ratio of the Gross enrolment ratio (%) of Secondary schools in Iran to that in Jamaica?
Provide a short and direct response. 1.04. What is the ratio of the Gross enrolment ratio (%) in Tertiary schools in Iran to that in Jamaica?
Keep it short and to the point. 0.14. What is the ratio of the Gross enrolment ratio (%) in Pre-primary schools in Iran to that in Japan?
Offer a very short reply. 0.16. What is the ratio of the Gross enrolment ratio (%) in Primary schools in Iran to that in Japan?
Offer a terse response. 0.8. What is the ratio of the Gross enrolment ratio (%) of Secondary schools in Iran to that in Japan?
Provide a short and direct response. 1.11. What is the ratio of the Gross enrolment ratio (%) in Tertiary schools in Iran to that in Japan?
Keep it short and to the point. 0.14. What is the ratio of the Gross enrolment ratio (%) of Pre-primary schools in Iran to that in Jordan?
Give a very brief answer. 0.3. What is the ratio of the Gross enrolment ratio (%) of Primary schools in Iran to that in Jordan?
Your answer should be very brief. 0.61. What is the ratio of the Gross enrolment ratio (%) in Secondary schools in Iran to that in Jordan?
Keep it short and to the point. 3.05. What is the ratio of the Gross enrolment ratio (%) in Tertiary schools in Iran to that in Jordan?
Provide a short and direct response. 0.05. What is the ratio of the Gross enrolment ratio (%) in Pre-primary schools in Ireland to that in Italy?
Your answer should be very brief. 1.11. What is the ratio of the Gross enrolment ratio (%) in Primary schools in Ireland to that in Italy?
Offer a very short reply. 0.86. What is the ratio of the Gross enrolment ratio (%) of Secondary schools in Ireland to that in Italy?
Offer a terse response. 0.84. What is the ratio of the Gross enrolment ratio (%) in Tertiary schools in Ireland to that in Italy?
Your answer should be very brief. 0.08. What is the ratio of the Gross enrolment ratio (%) in Pre-primary schools in Ireland to that in Jamaica?
Your answer should be compact. 1.39. What is the ratio of the Gross enrolment ratio (%) in Secondary schools in Ireland to that in Jamaica?
Your response must be concise. 0.84. What is the ratio of the Gross enrolment ratio (%) of Tertiary schools in Ireland to that in Jamaica?
Provide a short and direct response. 0.3. What is the ratio of the Gross enrolment ratio (%) of Pre-primary schools in Ireland to that in Japan?
Your answer should be very brief. 2.17. What is the ratio of the Gross enrolment ratio (%) in Primary schools in Ireland to that in Japan?
Make the answer very short. 0.9. What is the ratio of the Gross enrolment ratio (%) of Secondary schools in Ireland to that in Japan?
Ensure brevity in your answer.  0.89. What is the ratio of the Gross enrolment ratio (%) in Tertiary schools in Ireland to that in Japan?
Ensure brevity in your answer.  0.3. What is the ratio of the Gross enrolment ratio (%) in Pre-primary schools in Ireland to that in Jordan?
Your answer should be compact. 3.98. What is the ratio of the Gross enrolment ratio (%) of Primary schools in Ireland to that in Jordan?
Offer a terse response. 0.69. What is the ratio of the Gross enrolment ratio (%) in Secondary schools in Ireland to that in Jordan?
Keep it short and to the point. 2.47. What is the ratio of the Gross enrolment ratio (%) in Tertiary schools in Ireland to that in Jordan?
Make the answer very short. 0.11. What is the ratio of the Gross enrolment ratio (%) of Pre-primary schools in Italy to that in Jamaica?
Give a very brief answer. 1.25. What is the ratio of the Gross enrolment ratio (%) in Primary schools in Italy to that in Jamaica?
Your answer should be compact. 1.17. What is the ratio of the Gross enrolment ratio (%) of Tertiary schools in Italy to that in Jamaica?
Give a very brief answer. 3.81. What is the ratio of the Gross enrolment ratio (%) of Pre-primary schools in Italy to that in Japan?
Give a very brief answer. 1.96. What is the ratio of the Gross enrolment ratio (%) of Primary schools in Italy to that in Japan?
Ensure brevity in your answer.  1.05. What is the ratio of the Gross enrolment ratio (%) of Secondary schools in Italy to that in Japan?
Your response must be concise. 1.06. What is the ratio of the Gross enrolment ratio (%) in Tertiary schools in Italy to that in Japan?
Ensure brevity in your answer.  3.86. What is the ratio of the Gross enrolment ratio (%) of Pre-primary schools in Italy to that in Jordan?
Provide a succinct answer. 3.6. What is the ratio of the Gross enrolment ratio (%) in Primary schools in Italy to that in Jordan?
Make the answer very short. 0.8. What is the ratio of the Gross enrolment ratio (%) of Secondary schools in Italy to that in Jordan?
Offer a very short reply. 2.92. What is the ratio of the Gross enrolment ratio (%) of Tertiary schools in Italy to that in Jordan?
Offer a very short reply. 1.44. What is the ratio of the Gross enrolment ratio (%) of Pre-primary schools in Jamaica to that in Japan?
Give a very brief answer. 1.57. What is the ratio of the Gross enrolment ratio (%) of Primary schools in Jamaica to that in Japan?
Ensure brevity in your answer.  0.9. What is the ratio of the Gross enrolment ratio (%) in Secondary schools in Jamaica to that in Japan?
Your response must be concise. 1.06. What is the ratio of the Gross enrolment ratio (%) in Tertiary schools in Jamaica to that in Japan?
Keep it short and to the point. 1.01. What is the ratio of the Gross enrolment ratio (%) of Pre-primary schools in Jamaica to that in Jordan?
Provide a short and direct response. 2.87. What is the ratio of the Gross enrolment ratio (%) of Primary schools in Jamaica to that in Jordan?
Provide a succinct answer. 0.69. What is the ratio of the Gross enrolment ratio (%) in Secondary schools in Jamaica to that in Jordan?
Offer a terse response. 2.93. What is the ratio of the Gross enrolment ratio (%) of Tertiary schools in Jamaica to that in Jordan?
Offer a very short reply. 0.38. What is the ratio of the Gross enrolment ratio (%) in Pre-primary schools in Japan to that in Jordan?
Ensure brevity in your answer.  1.83. What is the ratio of the Gross enrolment ratio (%) of Primary schools in Japan to that in Jordan?
Offer a terse response. 0.76. What is the ratio of the Gross enrolment ratio (%) in Secondary schools in Japan to that in Jordan?
Give a very brief answer. 2.76. What is the ratio of the Gross enrolment ratio (%) in Tertiary schools in Japan to that in Jordan?
Ensure brevity in your answer.  0.37. What is the difference between the highest and the second highest Gross enrolment ratio (%) in Pre-primary schools?
Keep it short and to the point. 10.22. What is the difference between the highest and the second highest Gross enrolment ratio (%) of Primary schools?
Provide a succinct answer. 24.14. What is the difference between the highest and the second highest Gross enrolment ratio (%) in Secondary schools?
Your response must be concise. 3.34. What is the difference between the highest and the second highest Gross enrolment ratio (%) of Tertiary schools?
Offer a very short reply. 6.67. What is the difference between the highest and the lowest Gross enrolment ratio (%) in Pre-primary schools?
Ensure brevity in your answer.  98.89. What is the difference between the highest and the lowest Gross enrolment ratio (%) of Primary schools?
Ensure brevity in your answer.  47.63. What is the difference between the highest and the lowest Gross enrolment ratio (%) in Secondary schools?
Make the answer very short. 57.68. What is the difference between the highest and the lowest Gross enrolment ratio (%) of Tertiary schools?
Ensure brevity in your answer.  20.9. 